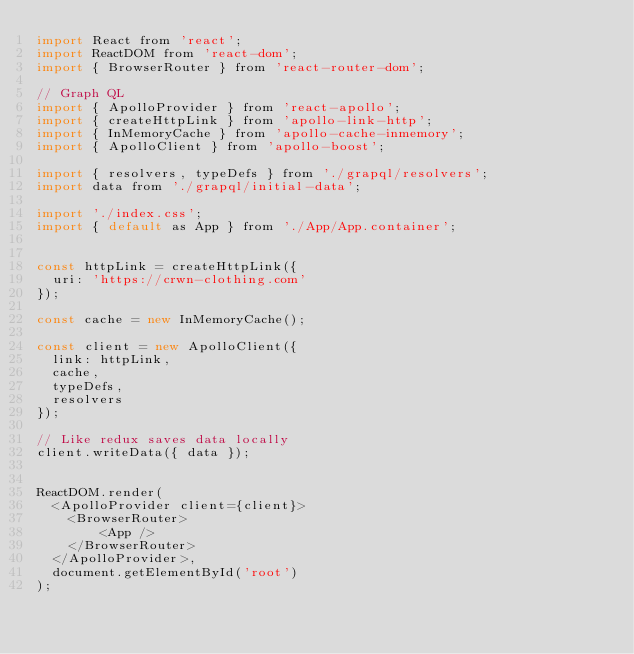Convert code to text. <code><loc_0><loc_0><loc_500><loc_500><_JavaScript_>import React from 'react';
import ReactDOM from 'react-dom';
import { BrowserRouter } from 'react-router-dom';

// Graph QL
import { ApolloProvider } from 'react-apollo';
import { createHttpLink } from 'apollo-link-http';
import { InMemoryCache } from 'apollo-cache-inmemory';
import { ApolloClient } from 'apollo-boost';

import { resolvers, typeDefs } from './grapql/resolvers';
import data from './grapql/initial-data';

import './index.css';
import { default as App } from './App/App.container';


const httpLink = createHttpLink({
  uri: 'https://crwn-clothing.com'
});

const cache = new InMemoryCache();

const client = new ApolloClient({
  link: httpLink,
  cache,
  typeDefs,
  resolvers
});

// Like redux saves data locally
client.writeData({ data });


ReactDOM.render(
  <ApolloProvider client={client}>
    <BrowserRouter>
        <App />
    </BrowserRouter>
  </ApolloProvider>,
  document.getElementById('root')
);
</code> 